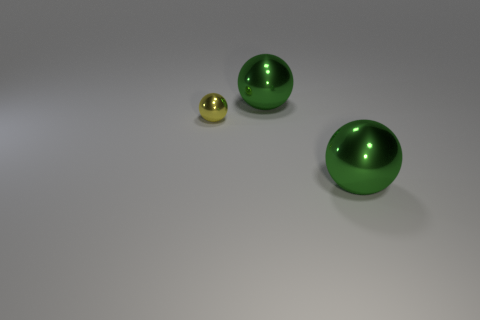Subtract 2 balls. How many balls are left? 1 Subtract all yellow metal spheres. How many spheres are left? 2 Add 1 small yellow shiny spheres. How many objects exist? 4 Subtract all yellow spheres. How many spheres are left? 2 Subtract all blue cubes. How many blue balls are left? 0 Add 3 yellow things. How many yellow things exist? 4 Subtract 0 red balls. How many objects are left? 3 Subtract all yellow balls. Subtract all green cylinders. How many balls are left? 2 Subtract all big blocks. Subtract all big green shiny balls. How many objects are left? 1 Add 3 metallic objects. How many metallic objects are left? 6 